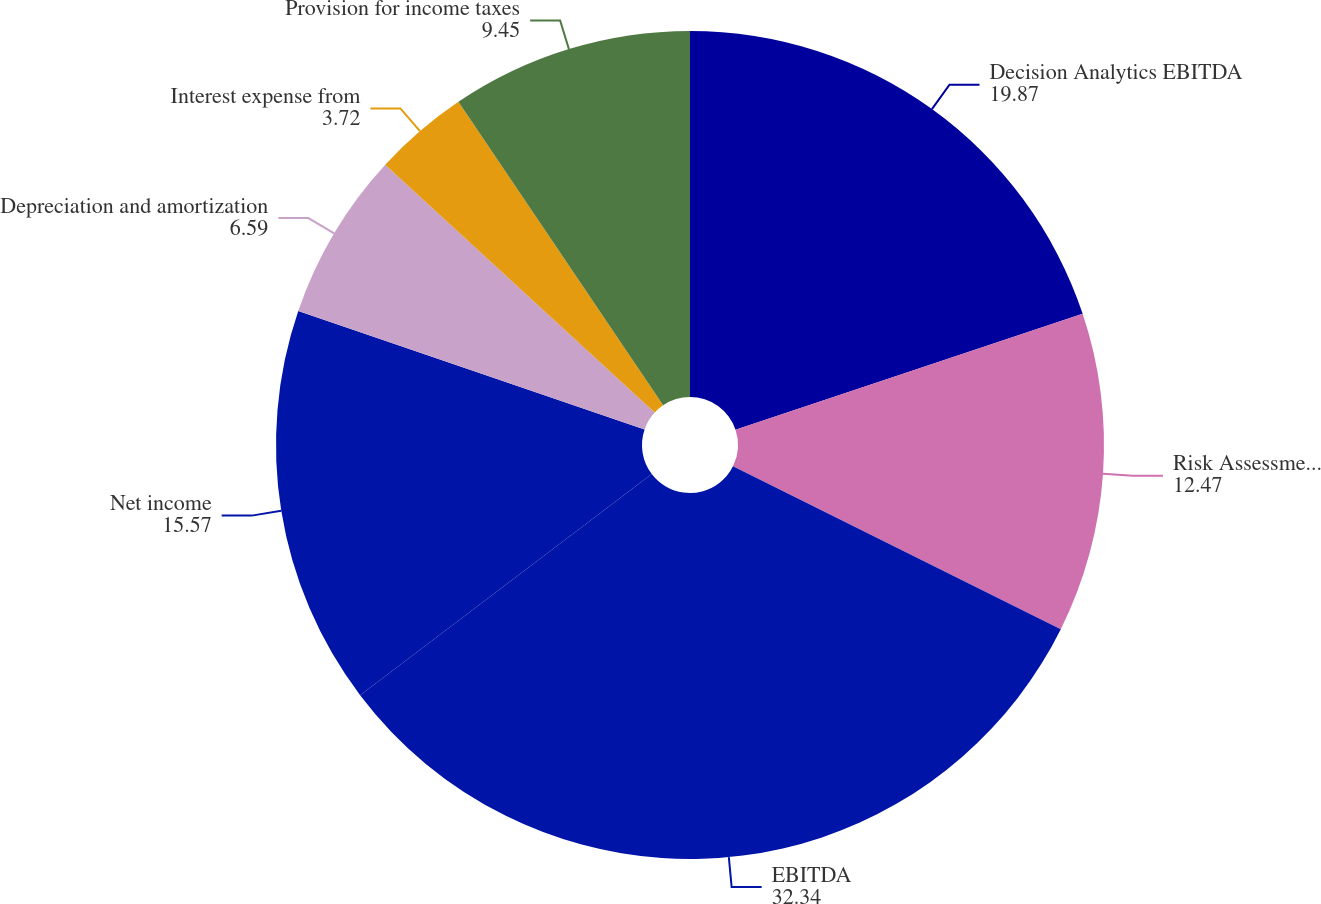Convert chart. <chart><loc_0><loc_0><loc_500><loc_500><pie_chart><fcel>Decision Analytics EBITDA<fcel>Risk Assessment EBITDA<fcel>EBITDA<fcel>Net income<fcel>Depreciation and amortization<fcel>Interest expense from<fcel>Provision for income taxes<nl><fcel>19.87%<fcel>12.47%<fcel>32.34%<fcel>15.57%<fcel>6.59%<fcel>3.72%<fcel>9.45%<nl></chart> 